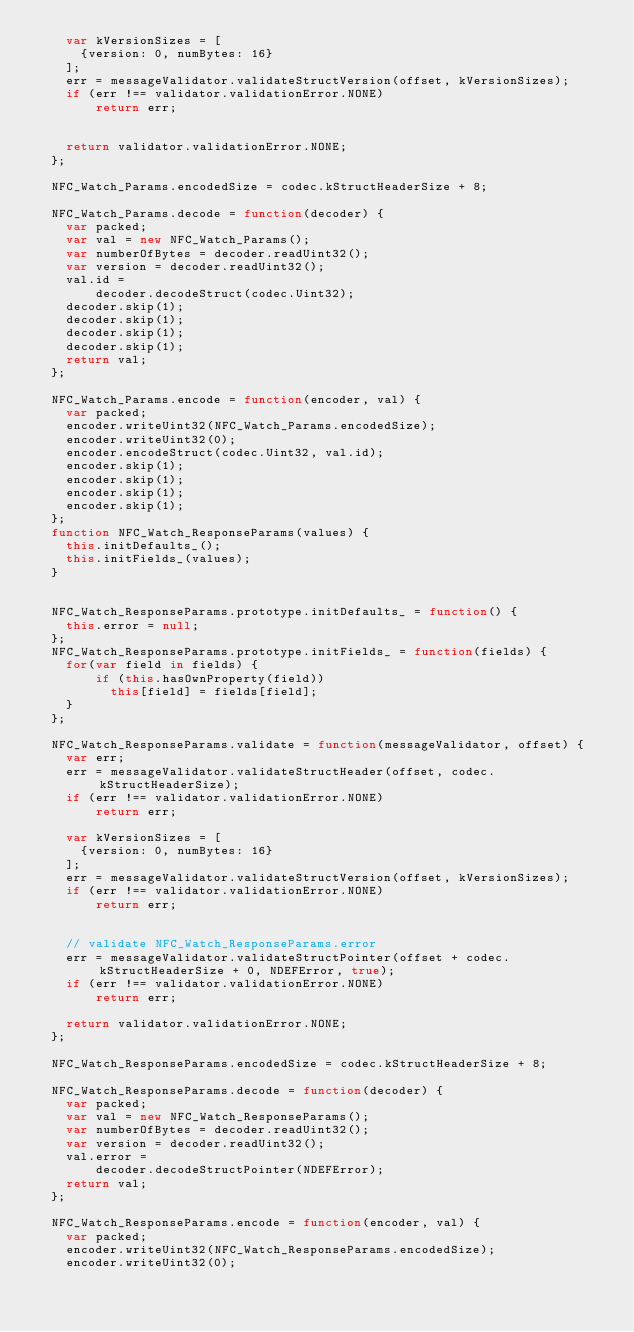<code> <loc_0><loc_0><loc_500><loc_500><_JavaScript_>    var kVersionSizes = [
      {version: 0, numBytes: 16}
    ];
    err = messageValidator.validateStructVersion(offset, kVersionSizes);
    if (err !== validator.validationError.NONE)
        return err;


    return validator.validationError.NONE;
  };

  NFC_Watch_Params.encodedSize = codec.kStructHeaderSize + 8;

  NFC_Watch_Params.decode = function(decoder) {
    var packed;
    var val = new NFC_Watch_Params();
    var numberOfBytes = decoder.readUint32();
    var version = decoder.readUint32();
    val.id =
        decoder.decodeStruct(codec.Uint32);
    decoder.skip(1);
    decoder.skip(1);
    decoder.skip(1);
    decoder.skip(1);
    return val;
  };

  NFC_Watch_Params.encode = function(encoder, val) {
    var packed;
    encoder.writeUint32(NFC_Watch_Params.encodedSize);
    encoder.writeUint32(0);
    encoder.encodeStruct(codec.Uint32, val.id);
    encoder.skip(1);
    encoder.skip(1);
    encoder.skip(1);
    encoder.skip(1);
  };
  function NFC_Watch_ResponseParams(values) {
    this.initDefaults_();
    this.initFields_(values);
  }


  NFC_Watch_ResponseParams.prototype.initDefaults_ = function() {
    this.error = null;
  };
  NFC_Watch_ResponseParams.prototype.initFields_ = function(fields) {
    for(var field in fields) {
        if (this.hasOwnProperty(field))
          this[field] = fields[field];
    }
  };

  NFC_Watch_ResponseParams.validate = function(messageValidator, offset) {
    var err;
    err = messageValidator.validateStructHeader(offset, codec.kStructHeaderSize);
    if (err !== validator.validationError.NONE)
        return err;

    var kVersionSizes = [
      {version: 0, numBytes: 16}
    ];
    err = messageValidator.validateStructVersion(offset, kVersionSizes);
    if (err !== validator.validationError.NONE)
        return err;


    // validate NFC_Watch_ResponseParams.error
    err = messageValidator.validateStructPointer(offset + codec.kStructHeaderSize + 0, NDEFError, true);
    if (err !== validator.validationError.NONE)
        return err;

    return validator.validationError.NONE;
  };

  NFC_Watch_ResponseParams.encodedSize = codec.kStructHeaderSize + 8;

  NFC_Watch_ResponseParams.decode = function(decoder) {
    var packed;
    var val = new NFC_Watch_ResponseParams();
    var numberOfBytes = decoder.readUint32();
    var version = decoder.readUint32();
    val.error =
        decoder.decodeStructPointer(NDEFError);
    return val;
  };

  NFC_Watch_ResponseParams.encode = function(encoder, val) {
    var packed;
    encoder.writeUint32(NFC_Watch_ResponseParams.encodedSize);
    encoder.writeUint32(0);</code> 